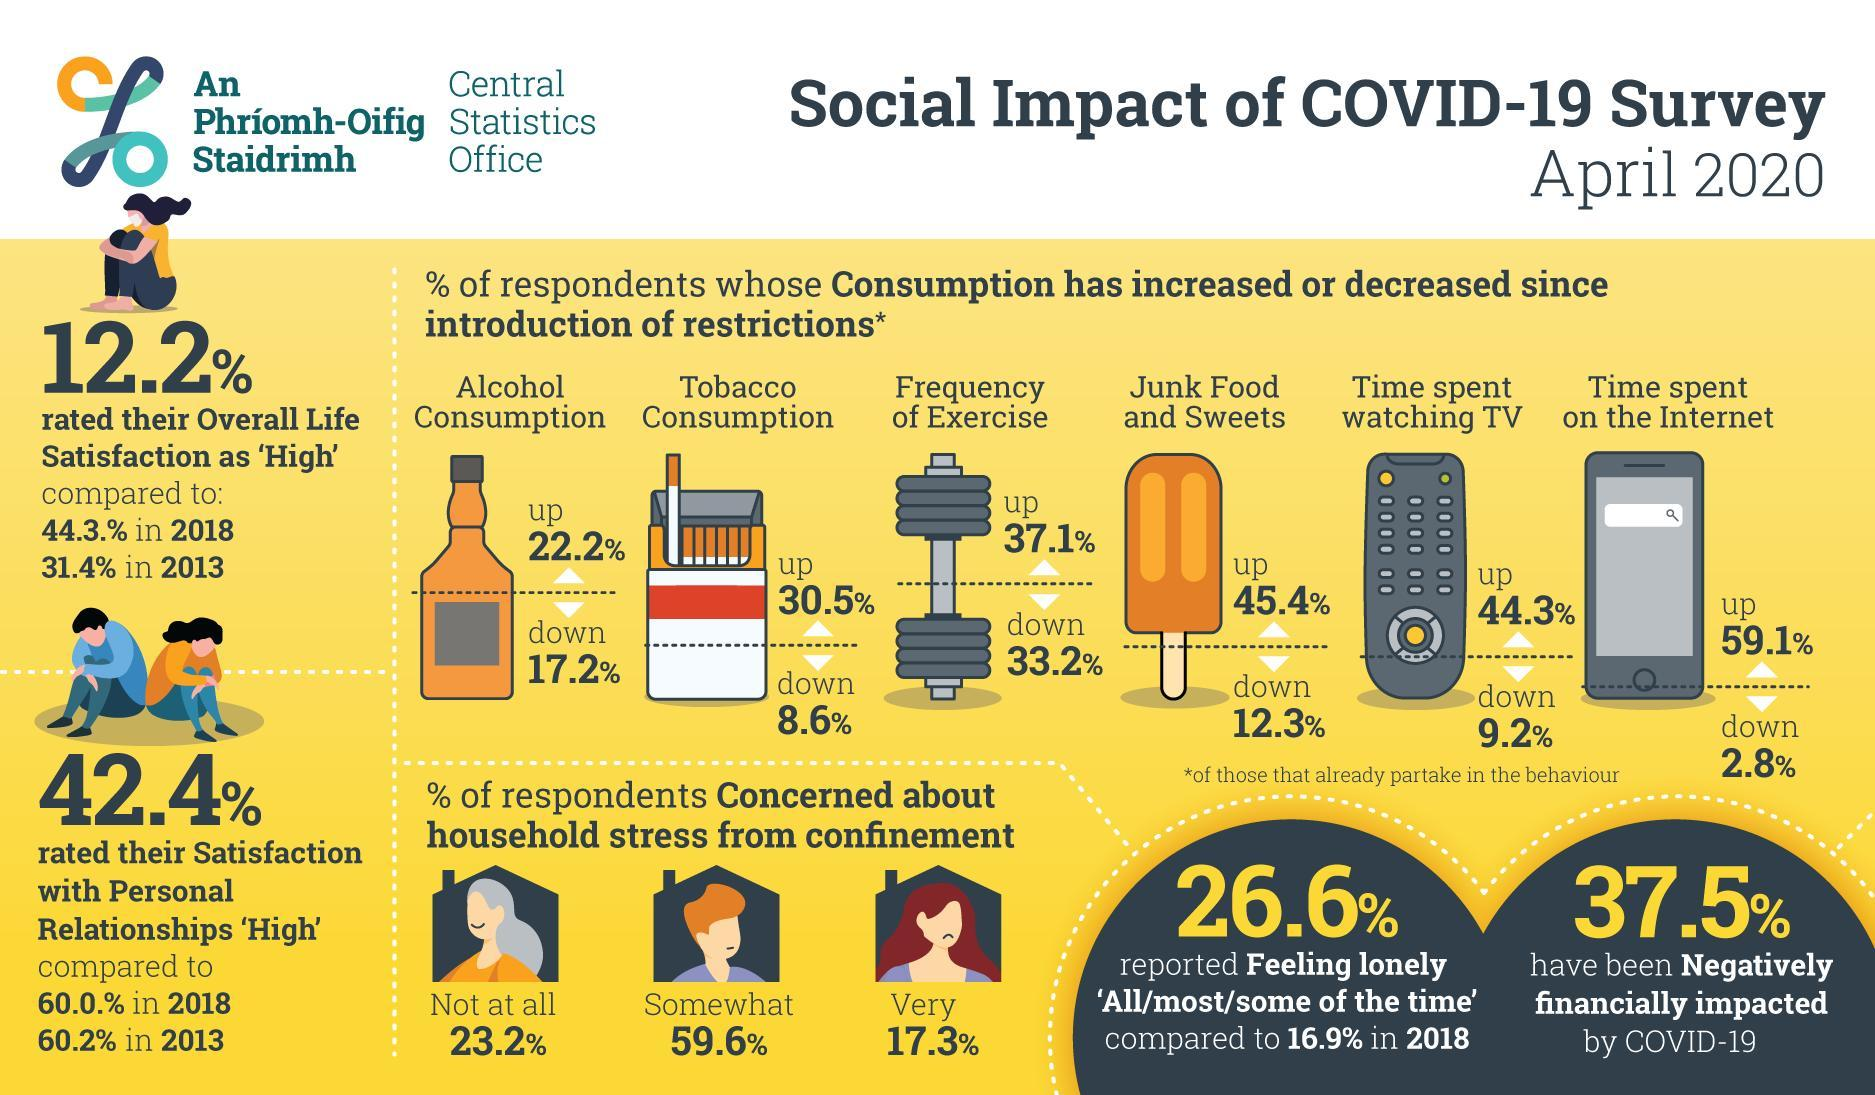What percent of respondents show an increase in the tobacco consumption since the introduction of restrictions?
Answer the question with a short phrase. 30.5% What percentage of respondents were very much concerned about the household stress from confinement due to the impact of COVID-19 as of April 2020? 17.3% What percent of respondents show an increase in the time spend by them on the internet since the introduction of restrictions? 59.1% What percent of respondents show an increase in the frequency of exercise since the introduction of restrictions? 37.1% What percentage of respondents were not at all concerned about the household stress from confinement due to the impact of COVID-19 as of April 2020? 23.2% What percent of respondents show a decrease in the time spend by them on watching TV since the introduction of restrictions? 9.2% 